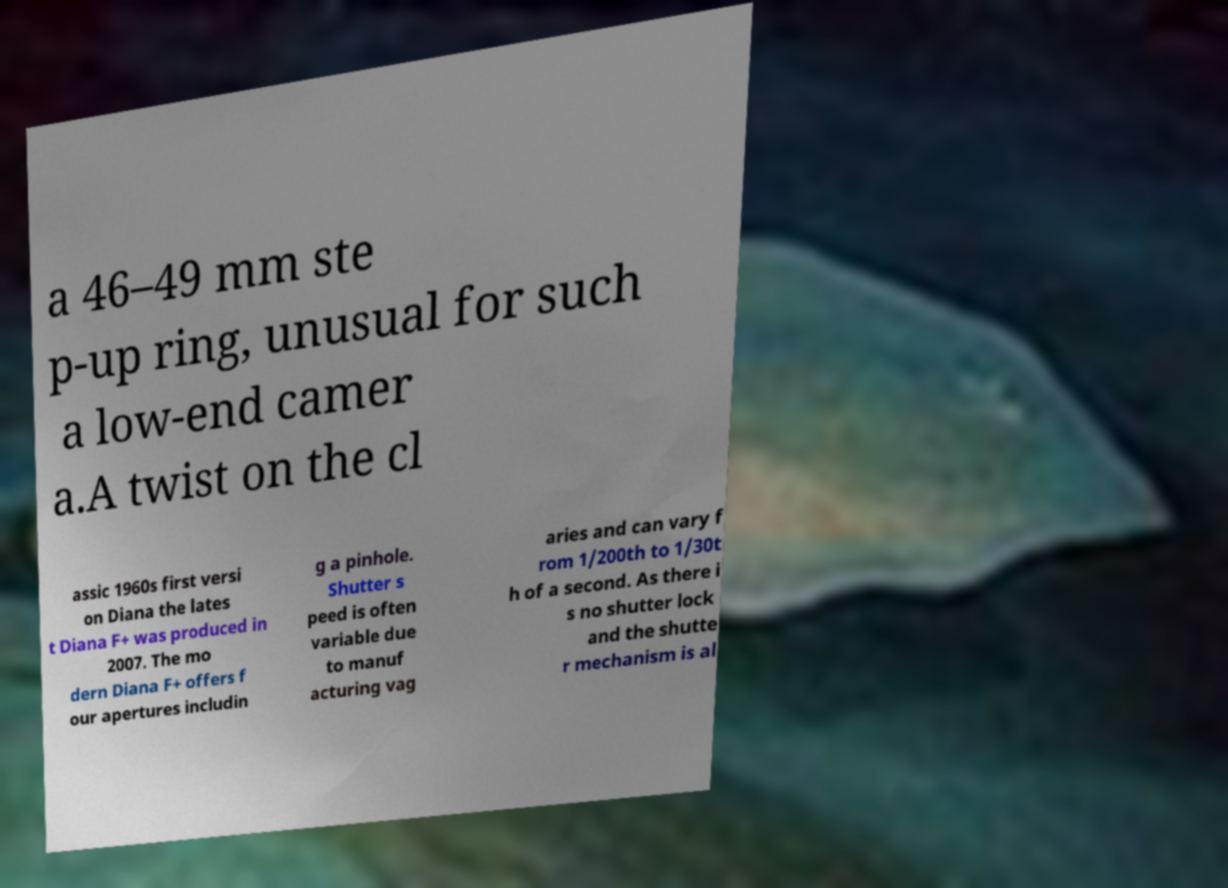I need the written content from this picture converted into text. Can you do that? a 46–49 mm ste p-up ring, unusual for such a low-end camer a.A twist on the cl assic 1960s first versi on Diana the lates t Diana F+ was produced in 2007. The mo dern Diana F+ offers f our apertures includin g a pinhole. Shutter s peed is often variable due to manuf acturing vag aries and can vary f rom 1/200th to 1/30t h of a second. As there i s no shutter lock and the shutte r mechanism is al 